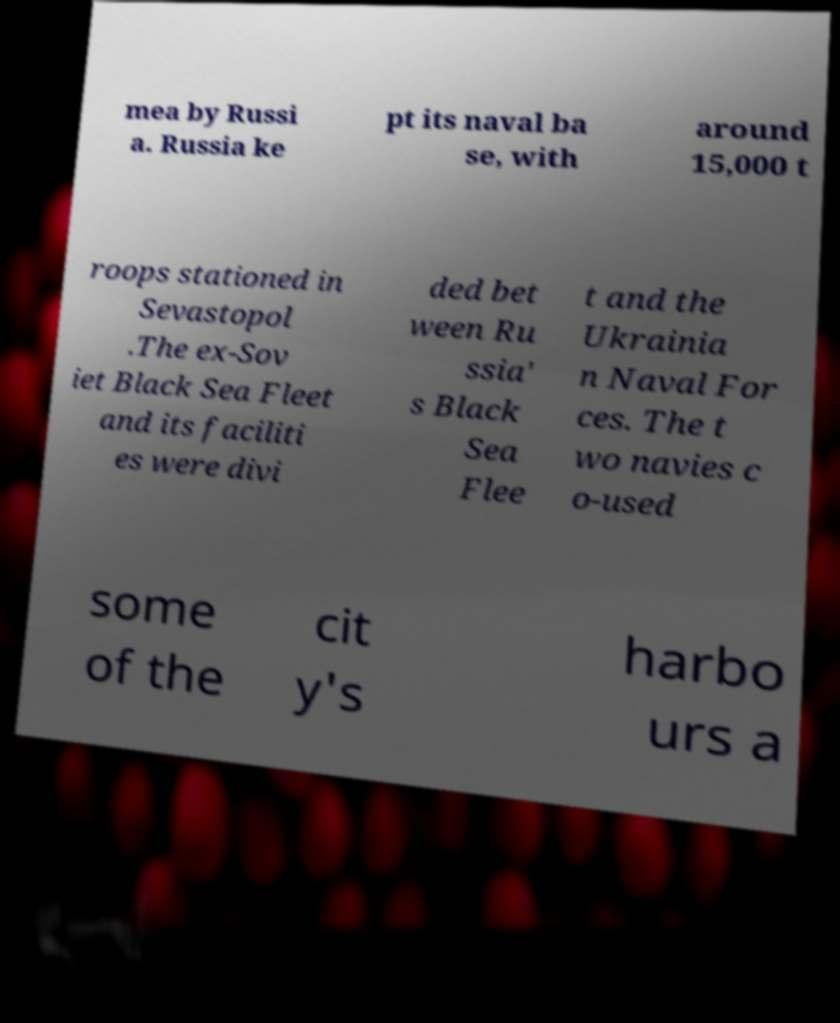Could you assist in decoding the text presented in this image and type it out clearly? mea by Russi a. Russia ke pt its naval ba se, with around 15,000 t roops stationed in Sevastopol .The ex-Sov iet Black Sea Fleet and its faciliti es were divi ded bet ween Ru ssia' s Black Sea Flee t and the Ukrainia n Naval For ces. The t wo navies c o-used some of the cit y's harbo urs a 